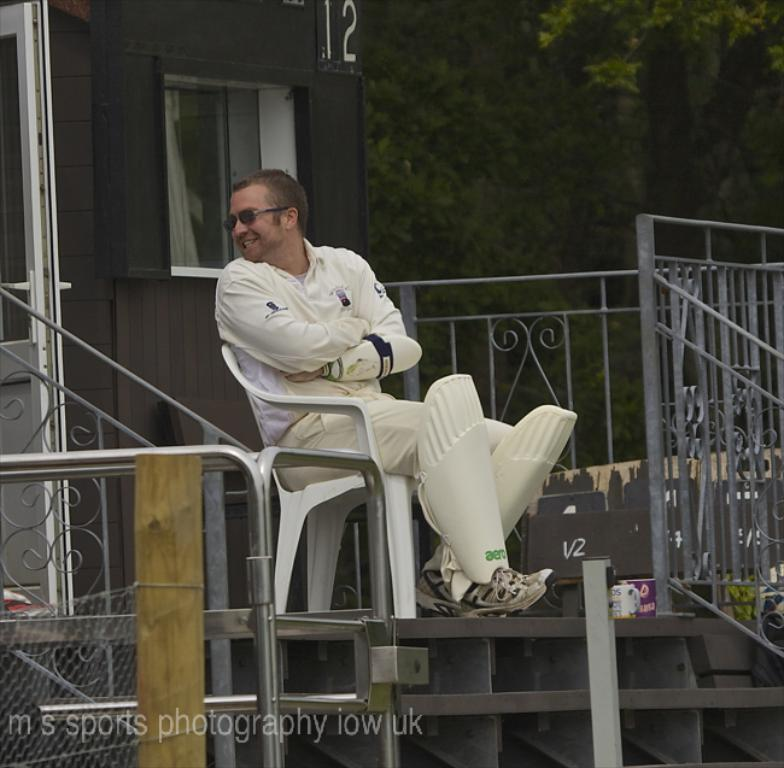What is the person in the image doing? There is a person sitting on a chair in the image. What can be seen in the background of the image? There is a fence and trees in the background of the image. How much tax does the person in the image have to pay? There is no information about taxes in the image, as it only shows a person sitting on a chair with a fence and trees in the background. 